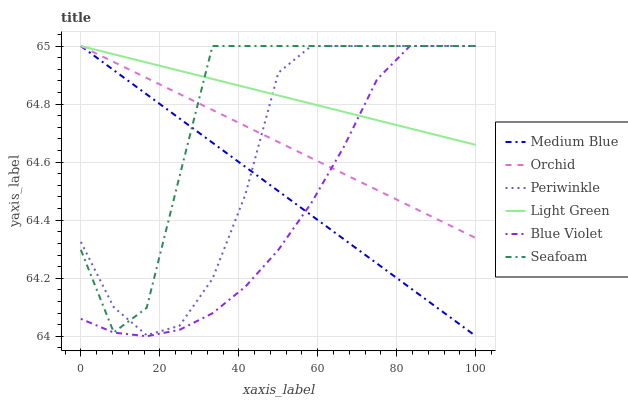Does Blue Violet have the minimum area under the curve?
Answer yes or no. Yes. Does Light Green have the maximum area under the curve?
Answer yes or no. Yes. Does Seafoam have the minimum area under the curve?
Answer yes or no. No. Does Seafoam have the maximum area under the curve?
Answer yes or no. No. Is Light Green the smoothest?
Answer yes or no. Yes. Is Seafoam the roughest?
Answer yes or no. Yes. Is Periwinkle the smoothest?
Answer yes or no. No. Is Periwinkle the roughest?
Answer yes or no. No. Does Blue Violet have the lowest value?
Answer yes or no. Yes. Does Seafoam have the lowest value?
Answer yes or no. No. Does Orchid have the highest value?
Answer yes or no. Yes. Does Orchid intersect Medium Blue?
Answer yes or no. Yes. Is Orchid less than Medium Blue?
Answer yes or no. No. Is Orchid greater than Medium Blue?
Answer yes or no. No. 